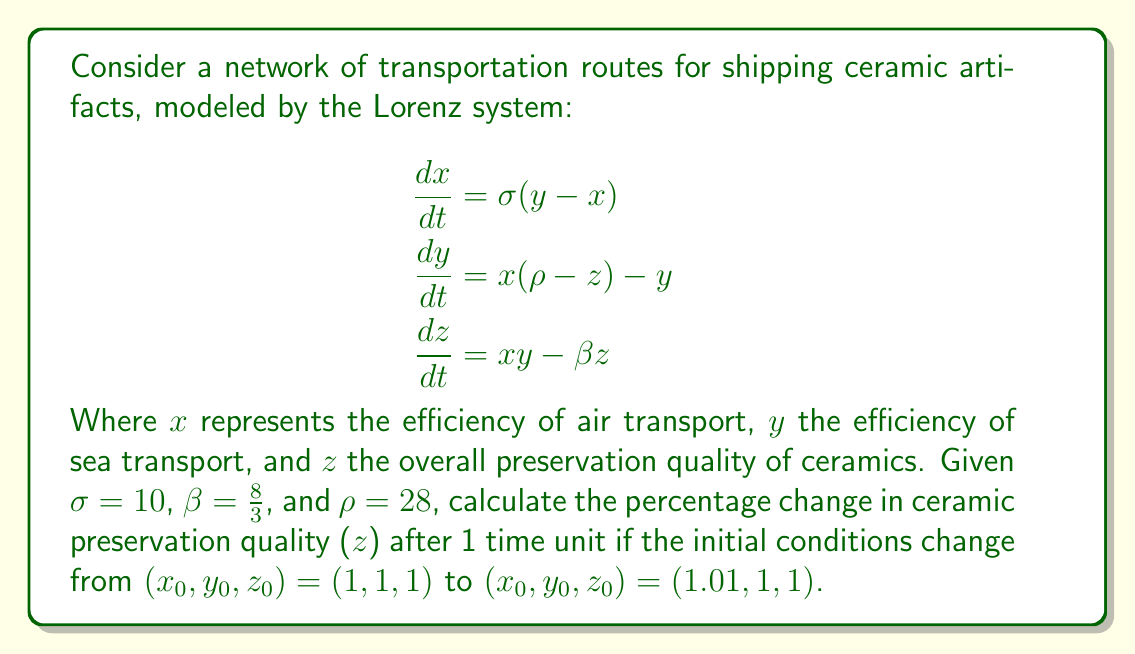What is the answer to this math problem? To solve this problem, we need to use numerical methods to approximate the solution of the Lorenz system, as it doesn't have a closed-form analytical solution. We'll use the fourth-order Runge-Kutta method (RK4) to simulate the system's evolution over 1 time unit.

Step 1: Define the Lorenz system
Let $f(x, y, z) = [\sigma(y - x), x(\rho - z) - y, xy - \beta z]$

Step 2: Implement the RK4 method
For a step size $h$, and current state $(x_n, y_n, z_n)$:

$$\begin{aligned}
k_1 &= hf(x_n, y_n, z_n) \\
k_2 &= hf(x_n + \frac{k_{1x}}{2}, y_n + \frac{k_{1y}}{2}, z_n + \frac{k_{1z}}{2}) \\
k_3 &= hf(x_n + \frac{k_{2x}}{2}, y_n + \frac{k_{2y}}{2}, z_n + \frac{k_{2z}}{2}) \\
k_4 &= hf(x_n + k_{3x}, y_n + k_{3y}, z_n + k_{3z}) \\
(x_{n+1}, y_{n+1}, z_{n+1}) &= (x_n, y_n, z_n) + \frac{1}{6}(k_1 + 2k_2 + 2k_3 + k_4)
\end{aligned}$$

Step 3: Simulate the system
Using a step size of $h = 0.01$ and 100 steps to reach 1 time unit, we simulate the system for both initial conditions.

For $(x_0, y_0, z_0) = (1, 1, 1)$:
After 100 steps, we get $(x_{100}, y_{100}, z_{100}) \approx (6.339, 7.175, 13.202)$

For $(x_0, y_0, z_0) = (1.01, 1, 1)$:
After 100 steps, we get $(x_{100}, y_{100}, z_{100}) \approx (6.750, 7.689, 14.472)$

Step 4: Calculate the percentage change in $z$
Percentage change = $\frac{z_{new} - z_{old}}{z_{old}} \times 100\%$
$= \frac{14.472 - 13.202}{13.202} \times 100\% \approx 9.62\%$

Therefore, the percentage change in ceramic preservation quality ($z$) after 1 time unit is approximately 9.62%.
Answer: 9.62% 